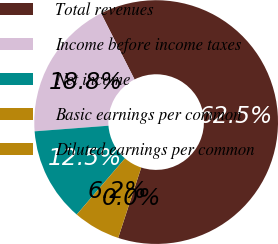Convert chart to OTSL. <chart><loc_0><loc_0><loc_500><loc_500><pie_chart><fcel>Total revenues<fcel>Income before income taxes<fcel>Net income<fcel>Basic earnings per common<fcel>Diluted earnings per common<nl><fcel>62.5%<fcel>18.75%<fcel>12.5%<fcel>6.25%<fcel>0.0%<nl></chart> 